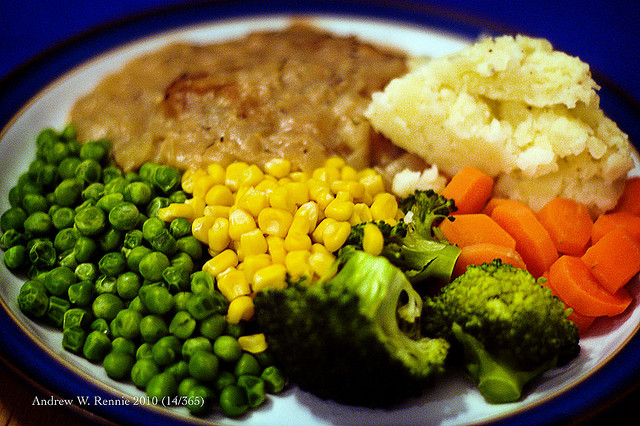<image>What container is the vegetable medley in? I am not sure what container the vegetable medley is in. However, it might be a plate. What container is the vegetable medley in? The vegetable medley is in a plate. 